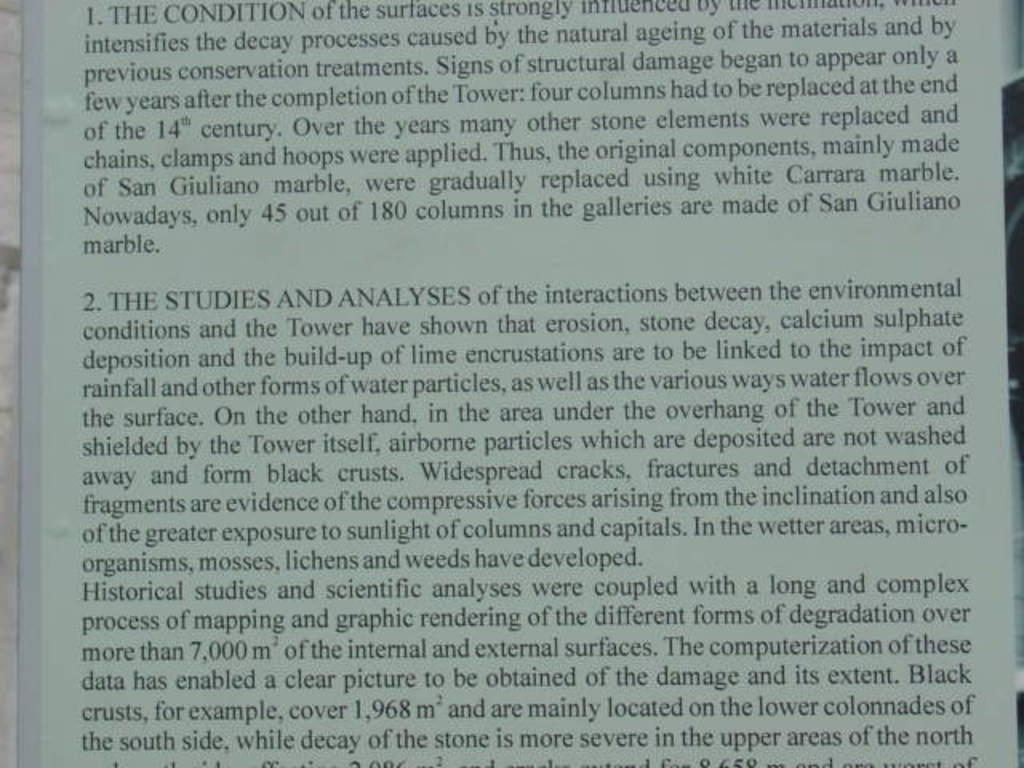<image>
Write a terse but informative summary of the picture. A book with a lot of writing about studies and analysis. 